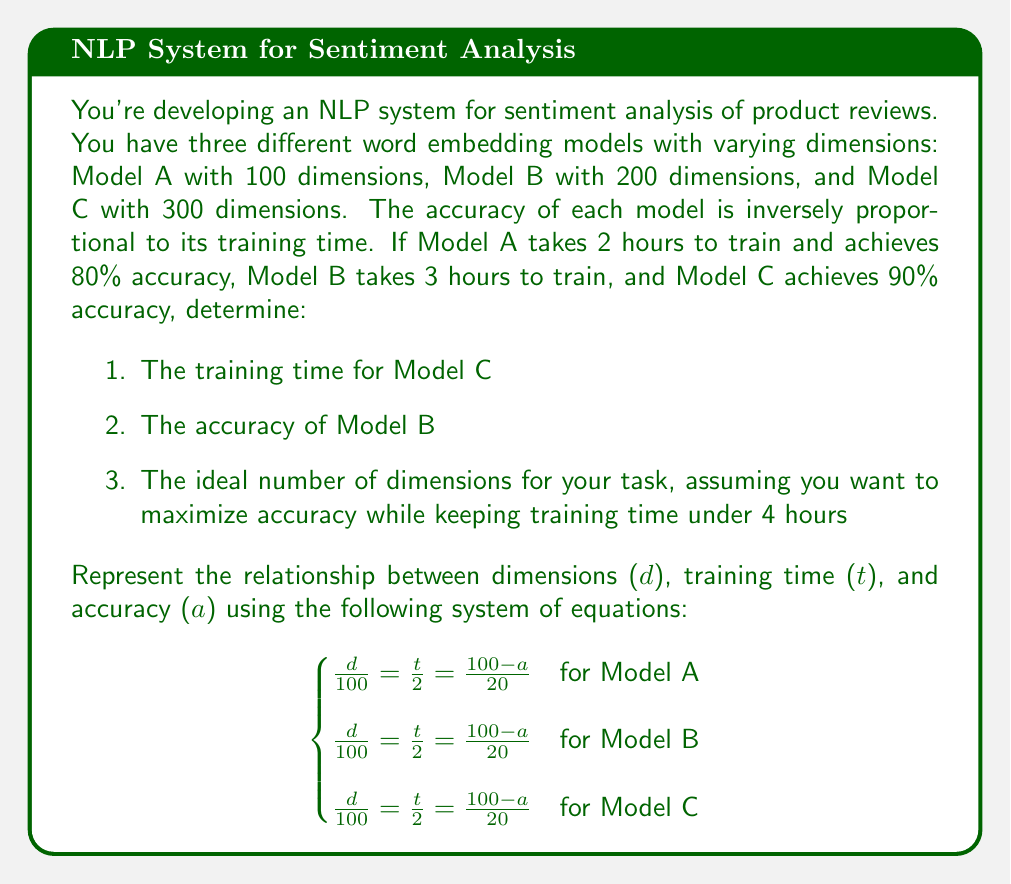Help me with this question. Let's solve this problem step by step:

1. First, let's use the given information to fill in the known values:

   Model A: $d = 100$, $t = 2$, $a = 80$
   Model B: $d = 200$, $t = 3$, $a = ?$
   Model C: $d = 300$, $t = ?$, $a = 90$

2. To find the training time for Model C:
   
   Using the equation $\frac{d}{100} = \frac{t}{2}$
   
   $\frac{300}{100} = \frac{t}{2}$
   
   $3 = \frac{t}{2}$
   
   $t = 6$ hours

3. To find the accuracy of Model B:
   
   Using the equation $\frac{d}{100} = \frac{100-a}{20}$
   
   $\frac{200}{100} = \frac{100-a}{20}$
   
   $2 = \frac{100-a}{20}$
   
   $40 = 100-a$
   
   $a = 60\%$

4. To find the ideal number of dimensions:
   
   We want to maximize accuracy while keeping training time under 4 hours.
   
   Using the equation $\frac{d}{100} = \frac{t}{2} = \frac{100-a}{20}$
   
   For $t = 4$, we get:
   
   $\frac{d}{100} = \frac{4}{2} = 2$
   
   $d = 200$
   
   To find the corresponding accuracy:
   
   $2 = \frac{100-a}{20}$
   
   $40 = 100-a$
   
   $a = 60\%$

   This matches Model B, which we already know has 200 dimensions and 60% accuracy.

Therefore, the ideal number of dimensions for your task, given the constraints, is 200.
Answer: 1. Training time for Model C: 6 hours
2. Accuracy of Model B: 60%
3. Ideal number of dimensions: 200 